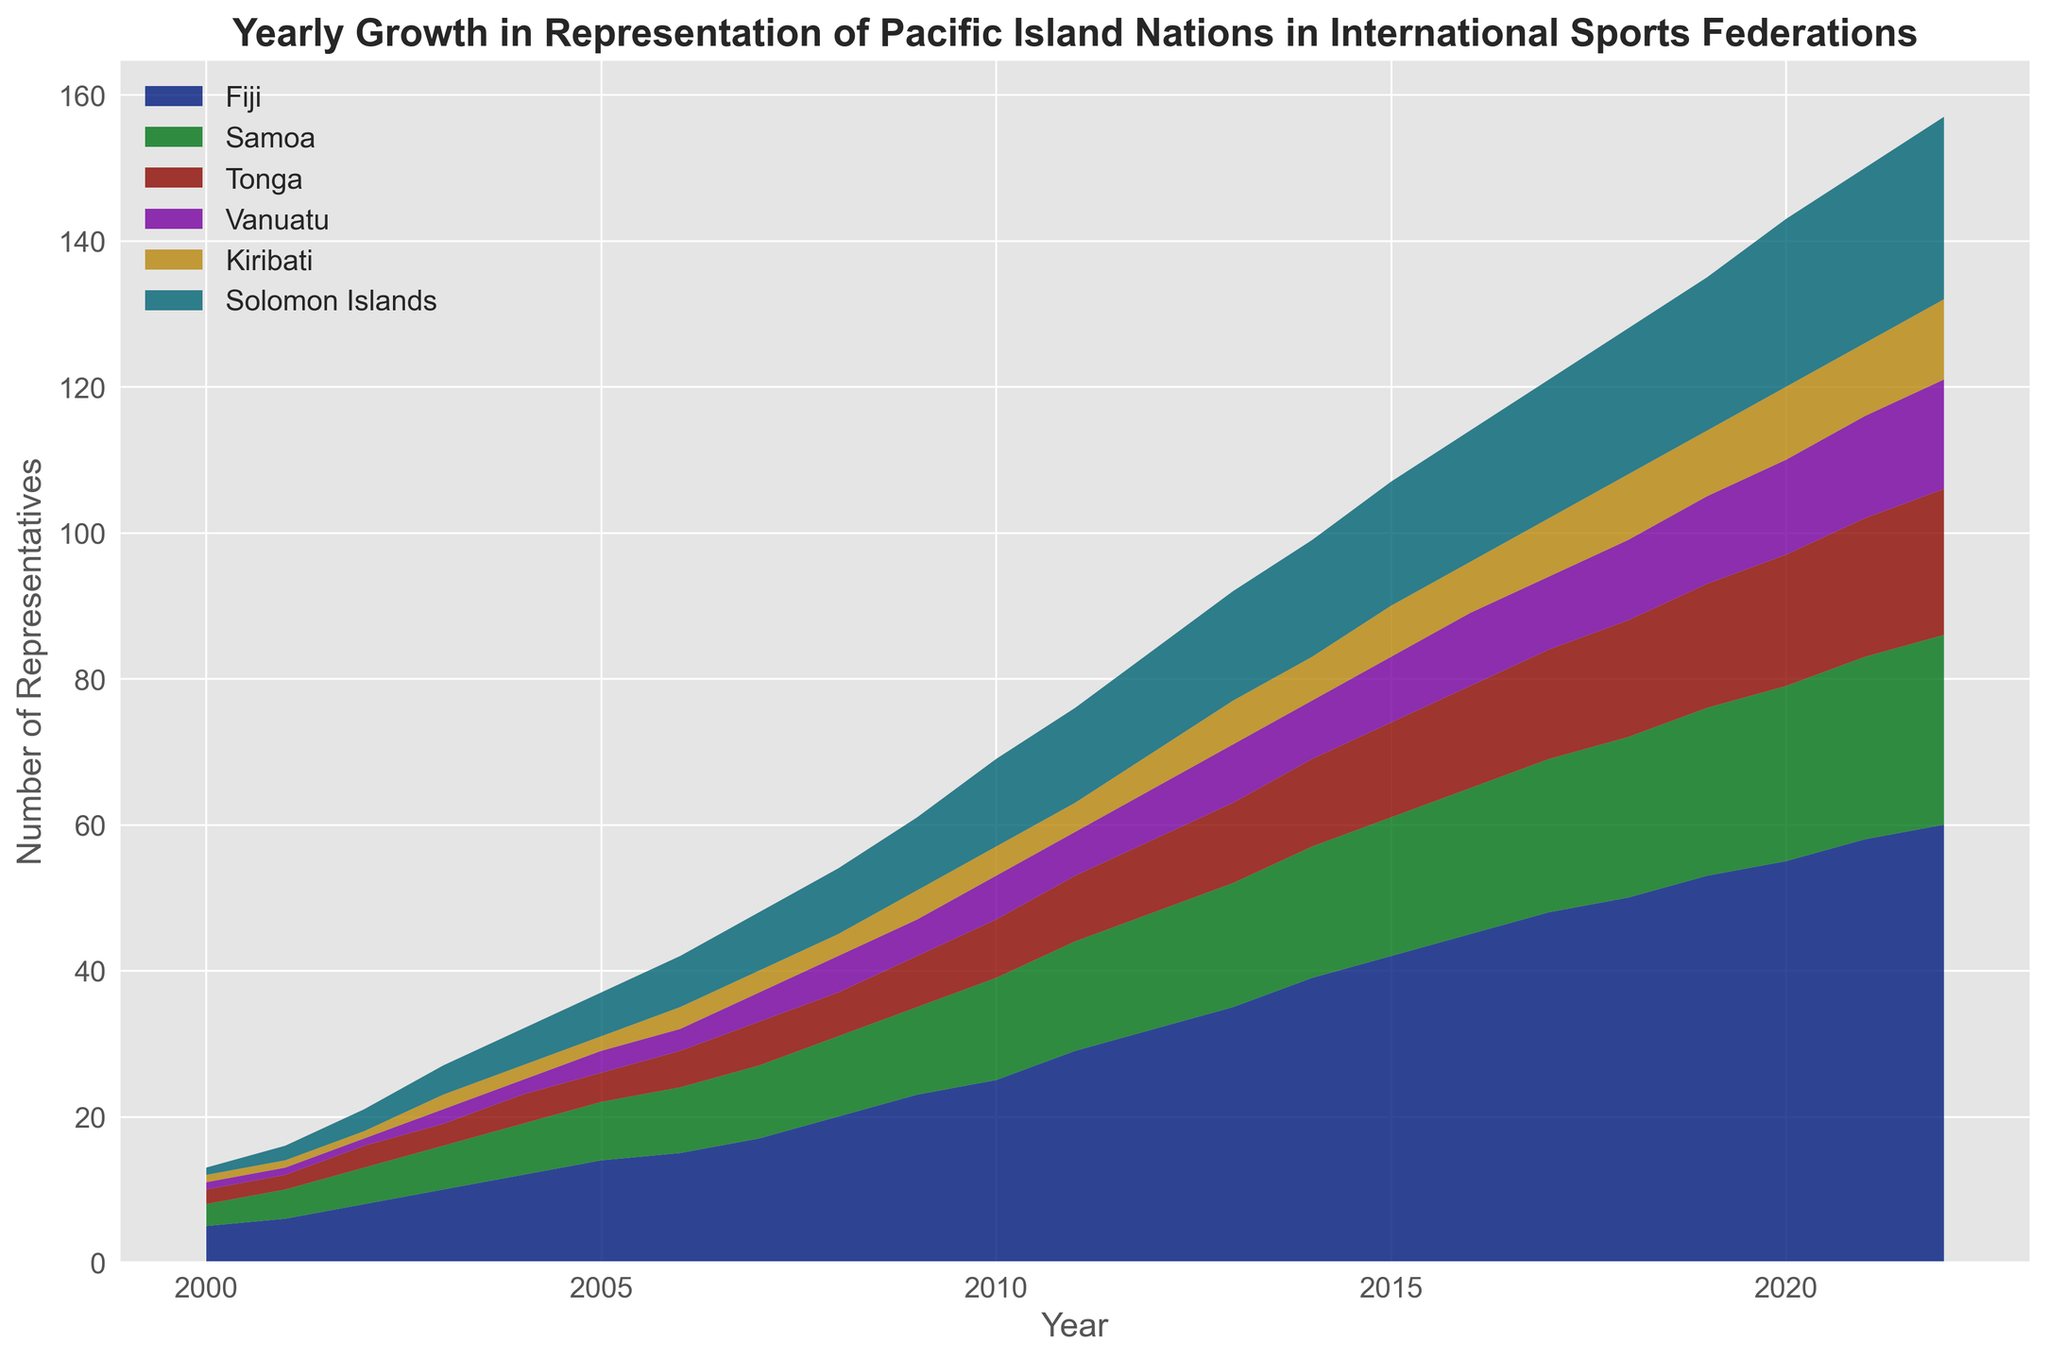Which country had the highest growth in representation over the period 2000-2022? To find the highest growth, look at the difference between the 2022 and 2000 values for each country. Fiji's growth is from 5 to 60, which is an increase of 55 representatives. Comparing this with other countries, Fiji has the highest increase.
Answer: Fiji Which country had a representation of 18 representatives first in the observed period? Check the year each country reached the count of 18 representatives. Fiji reached 18 representatives first in 2005.
Answer: Fiji What is the combined total representation for Vanuatu and Solomon Islands in 2022? Look at the 2022 values for Vanuatu (15) and Solomon Islands (25), then sum them up: 15 + 25
Answer: 40 How did Samoa's representation change from 2000 to 2010? Refer to Samoa's values in 2000 (3) and 2010 (14). The change is 14 - 3
Answer: 11 What is the average yearly growth in representation for Tonga over this period? Calculate the difference in representation from 2000 (2) to 2022 (20), which is 20 - 2 = 18. Divide by the number of years (2022 - 2000 = 22 years). 18 / 22
Answer: 0.82 Which countries had at least four representatives in 2004? Refer to the year 2004 and count the countries with at least 4 representatives: Fiji (12), Samoa (7), and Tonga (4).
Answer: Fiji, Samoa, and Tonga What was the total representation of all Pacific Island nations in 2015? Sum the values for all countries in 2015: 42 (Fiji) + 19 (Samoa) + 13 (Tonga) + 9 (Vanuatu) + 7 (Kiribati) + 17 (Solomon Islands), which is 42 + 19 + 13 + 9 + 7 + 17
Answer: 107 Which country showed the smallest growth rate from 2000 to 2022? Calculate the growth for each country. The smallest growth rate can be inferred by comparing the differences:
Fiji: 60-5 = 55, 
Samoa: 26-3 = 23,
Tonga: 20-2 = 18,
Vanuatu: 15-1 = 14,
Kiribati: 11-1 = 10,
Solomon Islands: 25-1 = 24.
The smallest growth is for Kiribati (10).
Answer: Kiribati In which year did Solomon Islands first surpass 10 representatives? Look for the year when Solomon Islands' value first exceeds 10. This happens in 2010.
Answer: 2010 